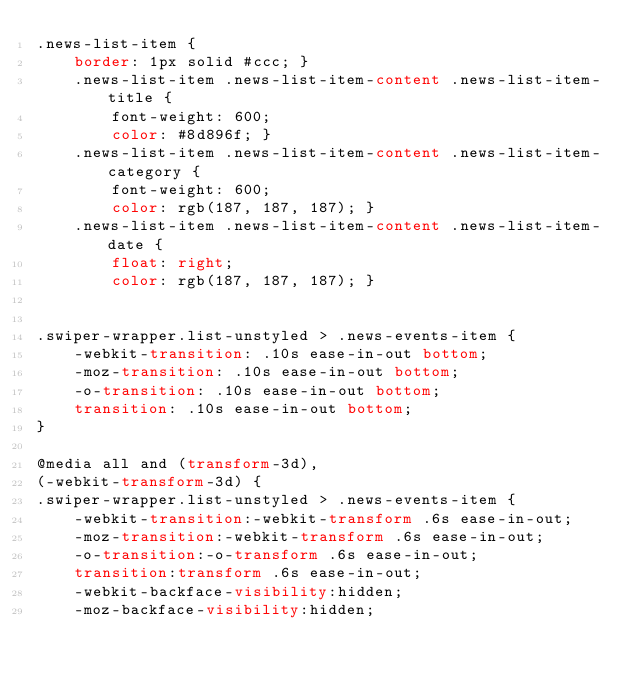Convert code to text. <code><loc_0><loc_0><loc_500><loc_500><_CSS_>.news-list-item {
    border: 1px solid #ccc; }
    .news-list-item .news-list-item-content .news-list-item-title {
        font-weight: 600;
        color: #8d896f; }
    .news-list-item .news-list-item-content .news-list-item-category {
        font-weight: 600;
        color: rgb(187, 187, 187); }
    .news-list-item .news-list-item-content .news-list-item-date {
        float: right; 
        color: rgb(187, 187, 187); }


.swiper-wrapper.list-unstyled > .news-events-item {
    -webkit-transition: .10s ease-in-out bottom;
    -moz-transition: .10s ease-in-out bottom;
    -o-transition: .10s ease-in-out bottom;
    transition: .10s ease-in-out bottom;
}

@media all and (transform-3d),
(-webkit-transform-3d) {
.swiper-wrapper.list-unstyled > .news-events-item {
    -webkit-transition:-webkit-transform .6s ease-in-out;
    -moz-transition:-webkit-transform .6s ease-in-out;
    -o-transition:-o-transform .6s ease-in-out;
    transition:transform .6s ease-in-out;
    -webkit-backface-visibility:hidden;
    -moz-backface-visibility:hidden;</code> 